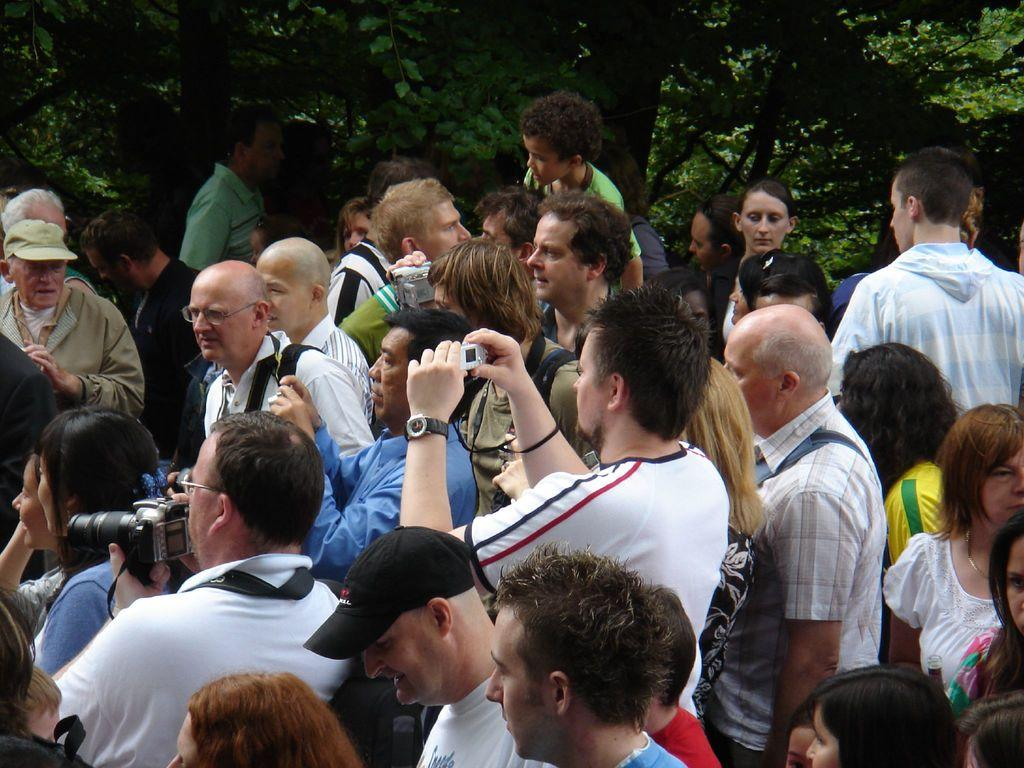What is the main subject of the image? The main subject of the image is a group of people. What are some of the people in the group holding? Some people in the group are holding cameras, while others are holding other objects. What can be seen in the background of the image? There are trees in the background of the image. How many flies can be seen on the table in the image? There is no table or flies present in the image; it features a group of people with some holding cameras and other objects. 